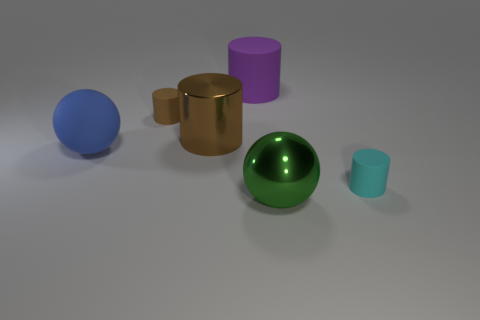The small matte object that is the same color as the large metal cylinder is what shape?
Offer a very short reply. Cylinder. There is a thing that is the same color as the big shiny cylinder; what is its size?
Provide a short and direct response. Small. What number of rubber cylinders are behind the sphere behind the large sphere right of the tiny brown cylinder?
Provide a short and direct response. 2. What color is the small rubber cylinder that is in front of the big brown shiny object?
Your answer should be very brief. Cyan. There is a tiny thing behind the cyan object; is it the same color as the rubber sphere?
Ensure brevity in your answer.  No. There is a brown matte object that is the same shape as the small cyan object; what is its size?
Your answer should be compact. Small. Is there any other thing that has the same size as the purple matte cylinder?
Keep it short and to the point. Yes. The small cylinder in front of the big metal thing that is behind the large sphere that is on the left side of the brown matte thing is made of what material?
Offer a terse response. Rubber. Is the number of big green spheres to the right of the big shiny sphere greater than the number of brown shiny cylinders that are behind the large brown metallic thing?
Provide a short and direct response. No. Is the purple rubber cylinder the same size as the green metallic object?
Your response must be concise. Yes. 